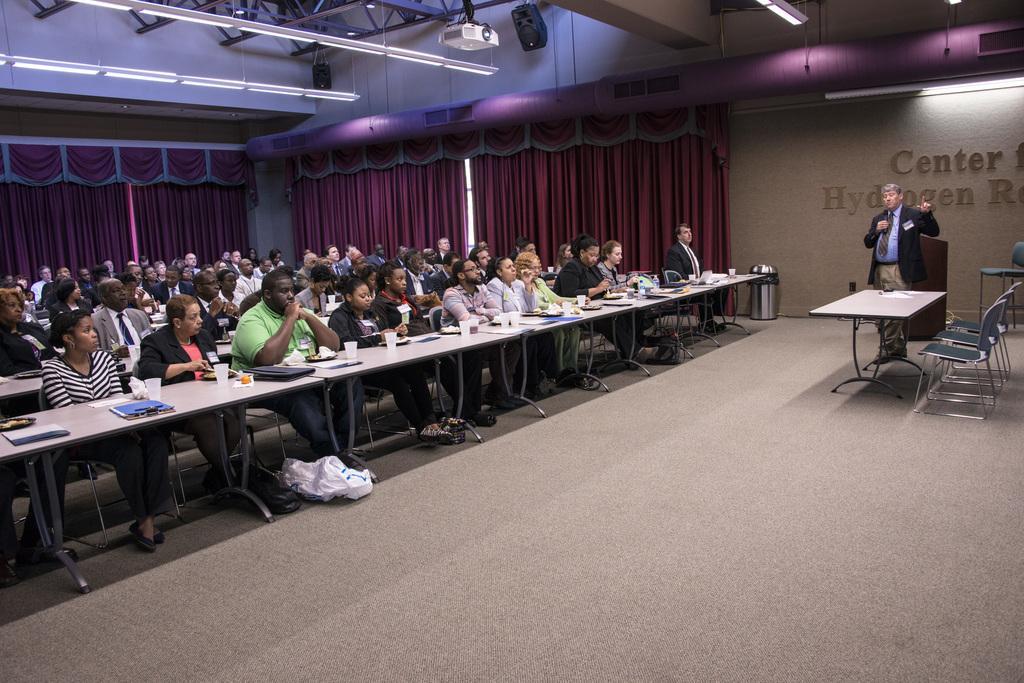How would you summarize this image in a sentence or two? In the picture we can see a group of people sitting on the chairs near the tables. On the tables we can see laptops, glasses, water. And one man is standing and explaining something to the people. In the background we can see the curtain which is red in colour and something written on the wall center for hydrogen, in the ceiling we can see a lights, stands and music box. 